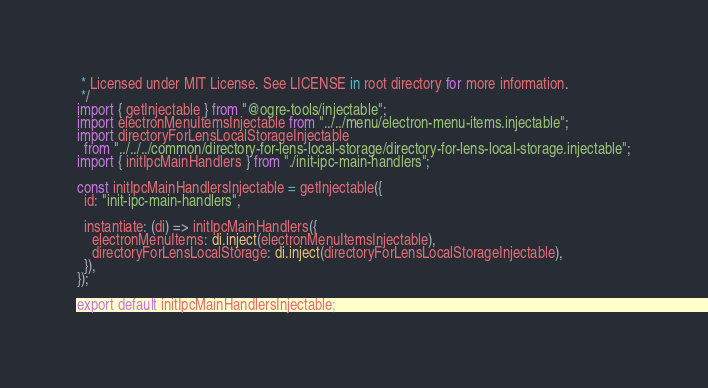<code> <loc_0><loc_0><loc_500><loc_500><_TypeScript_> * Licensed under MIT License. See LICENSE in root directory for more information.
 */
import { getInjectable } from "@ogre-tools/injectable";
import electronMenuItemsInjectable from "../../menu/electron-menu-items.injectable";
import directoryForLensLocalStorageInjectable
  from "../../../common/directory-for-lens-local-storage/directory-for-lens-local-storage.injectable";
import { initIpcMainHandlers } from "./init-ipc-main-handlers";

const initIpcMainHandlersInjectable = getInjectable({
  id: "init-ipc-main-handlers",

  instantiate: (di) => initIpcMainHandlers({
    electronMenuItems: di.inject(electronMenuItemsInjectable),
    directoryForLensLocalStorage: di.inject(directoryForLensLocalStorageInjectable),
  }),
});

export default initIpcMainHandlersInjectable;
</code> 